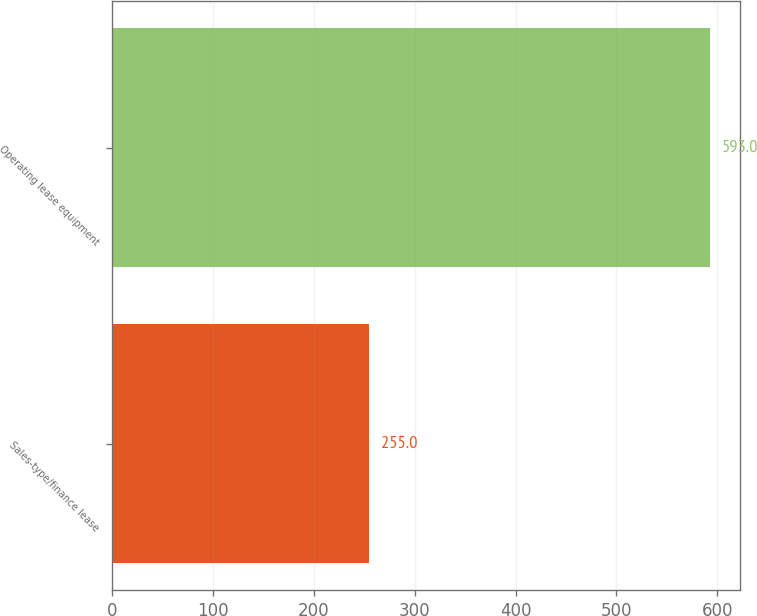Convert chart. <chart><loc_0><loc_0><loc_500><loc_500><bar_chart><fcel>Sales-type/finance lease<fcel>Operating lease equipment<nl><fcel>255<fcel>593<nl></chart> 